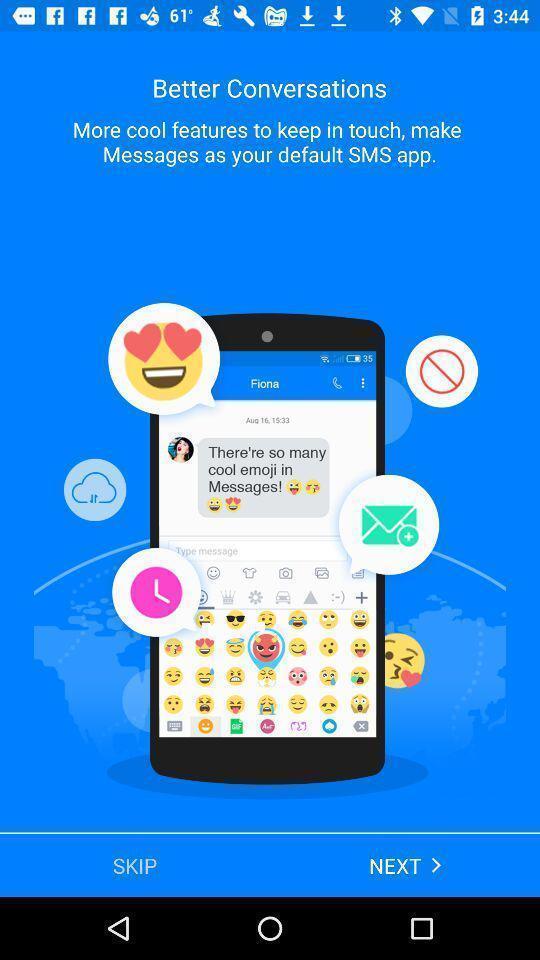What details can you identify in this image? Screen displaying the features. 